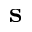Convert formula to latex. <formula><loc_0><loc_0><loc_500><loc_500>s</formula> 